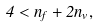Convert formula to latex. <formula><loc_0><loc_0><loc_500><loc_500>4 < n _ { f } + 2 n _ { v } ,</formula> 